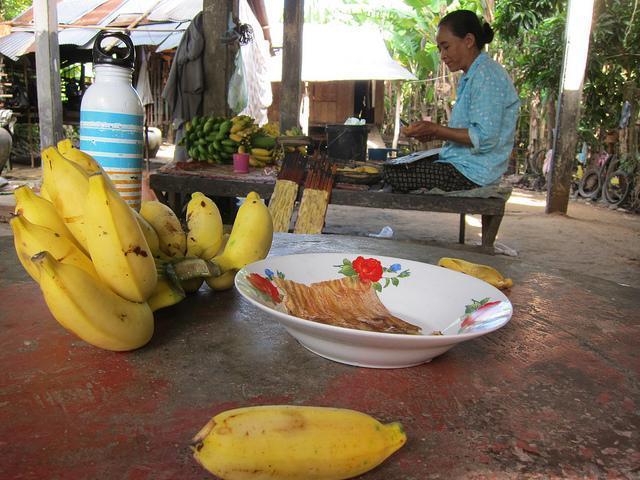How many bananas are pulled from the bunch?
Give a very brief answer. 2. How many dining tables are visible?
Give a very brief answer. 2. How many bananas are there?
Give a very brief answer. 3. 